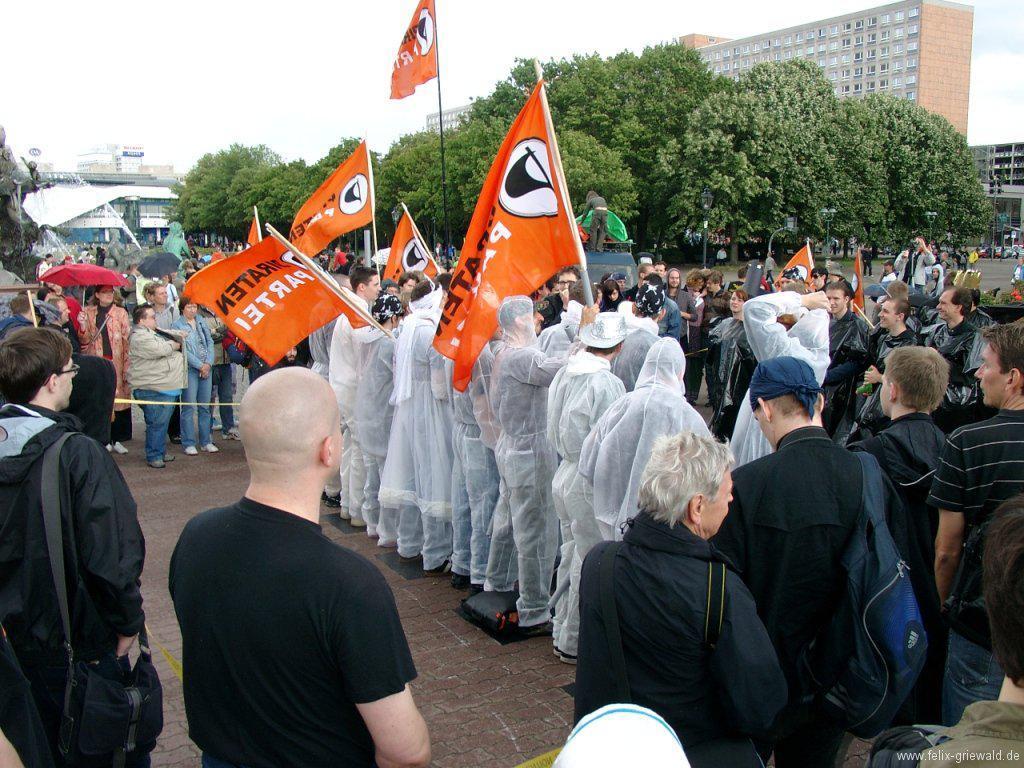Can you describe this image briefly? In this picture we can see there are groups of people standing and some people are holding the flags. Behind the people, there are trees and buildings. At the top of the image, there is the sky. At the bottom right corner of the image, there is a watermark. 